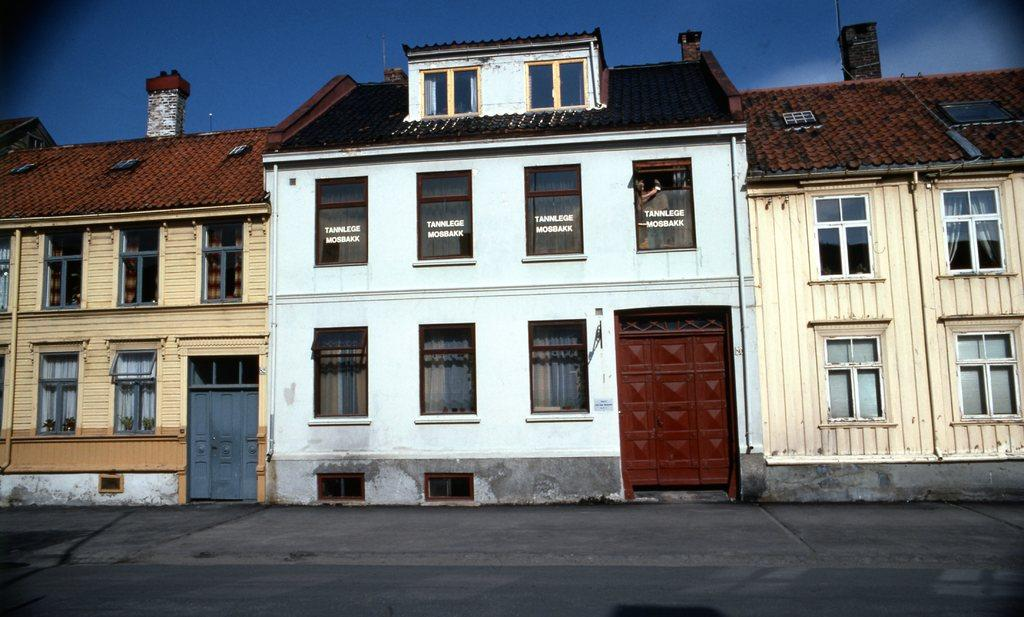What type of buildings are shown in the image? The buildings in the image have glass windows. What features do the buildings have? The buildings have doors. What else can be seen in the image besides the buildings? There are other objects in the image. What is visible at the bottom of the image? The floor is visible at the bottom of the image. What is visible in the background of the image? The sky is visible in the background of the image. What type of drug is being sold at the dock in the image? There is no dock or drug present in the image. How many fingers can be seen pointing at the buildings in the image? There are no fingers visible in the image. 